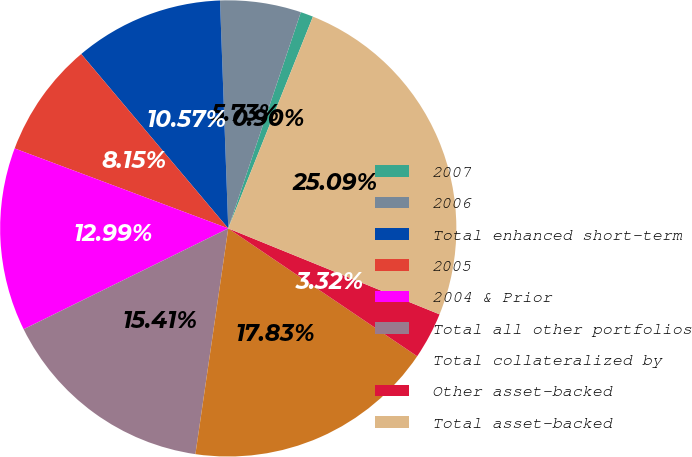Convert chart. <chart><loc_0><loc_0><loc_500><loc_500><pie_chart><fcel>2007<fcel>2006<fcel>Total enhanced short-term<fcel>2005<fcel>2004 & Prior<fcel>Total all other portfolios<fcel>Total collateralized by<fcel>Other asset-backed<fcel>Total asset-backed<nl><fcel>0.9%<fcel>5.73%<fcel>10.57%<fcel>8.15%<fcel>12.99%<fcel>15.41%<fcel>17.83%<fcel>3.32%<fcel>25.09%<nl></chart> 